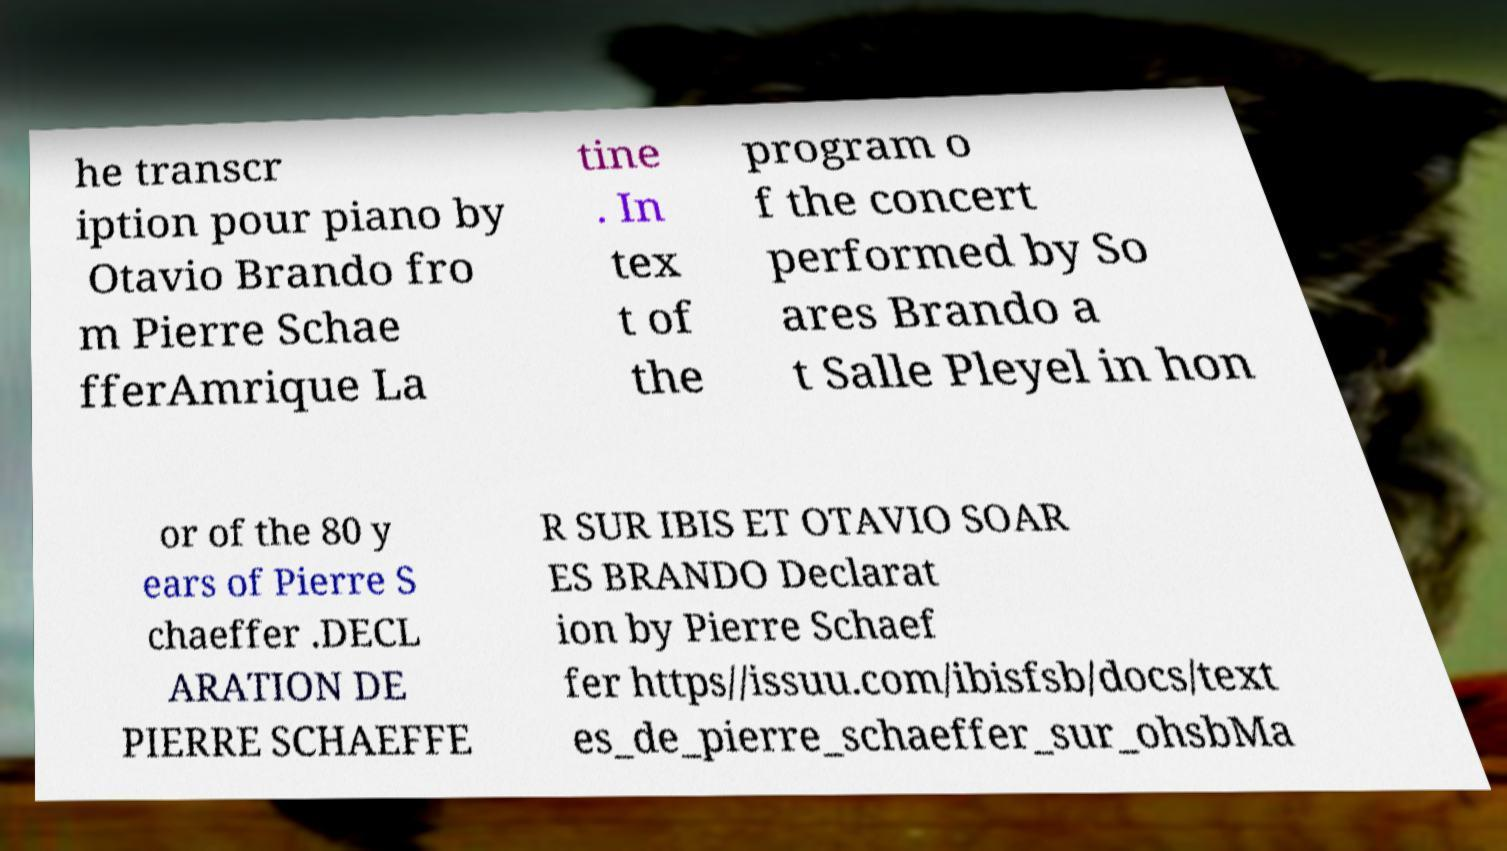For documentation purposes, I need the text within this image transcribed. Could you provide that? he transcr iption pour piano by Otavio Brando fro m Pierre Schae fferAmrique La tine . In tex t of the program o f the concert performed by So ares Brando a t Salle Pleyel in hon or of the 80 y ears of Pierre S chaeffer .DECL ARATION DE PIERRE SCHAEFFE R SUR IBIS ET OTAVIO SOAR ES BRANDO Declarat ion by Pierre Schaef fer https//issuu.com/ibisfsb/docs/text es_de_pierre_schaeffer_sur_ohsbMa 